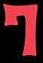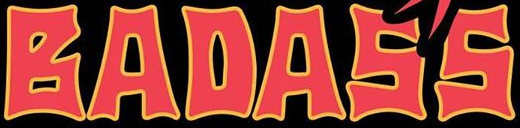Transcribe the words shown in these images in order, separated by a semicolon. 7; BADASS 